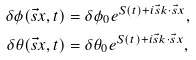<formula> <loc_0><loc_0><loc_500><loc_500>\delta \phi ( \vec { s } { x } , t ) & = \delta \phi _ { 0 } e ^ { S ( t ) + i { \vec { s } k } \cdot { \vec { s } x } } , \\ \delta \theta ( \vec { s } { x } , t ) & = \delta \theta _ { 0 } e ^ { S ( t ) + i { \vec { s } k } \cdot { \vec { s } x } } ,</formula> 